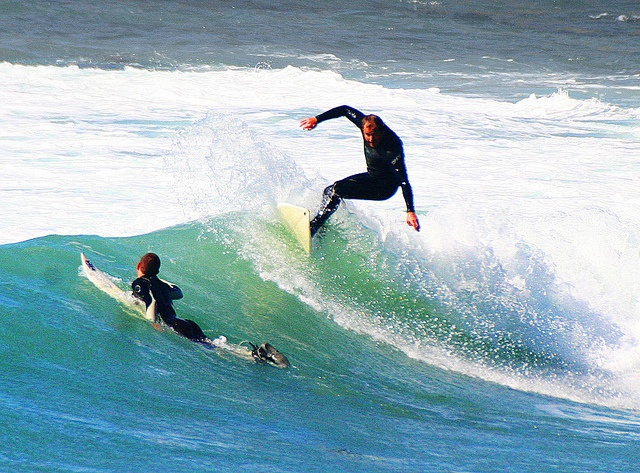Describe the objects in this image and their specific colors. I can see people in gray, black, navy, and white tones, people in gray, black, navy, and teal tones, surfboard in gray, beige, khaki, black, and tan tones, and surfboard in gray, beige, darkgray, and teal tones in this image. 